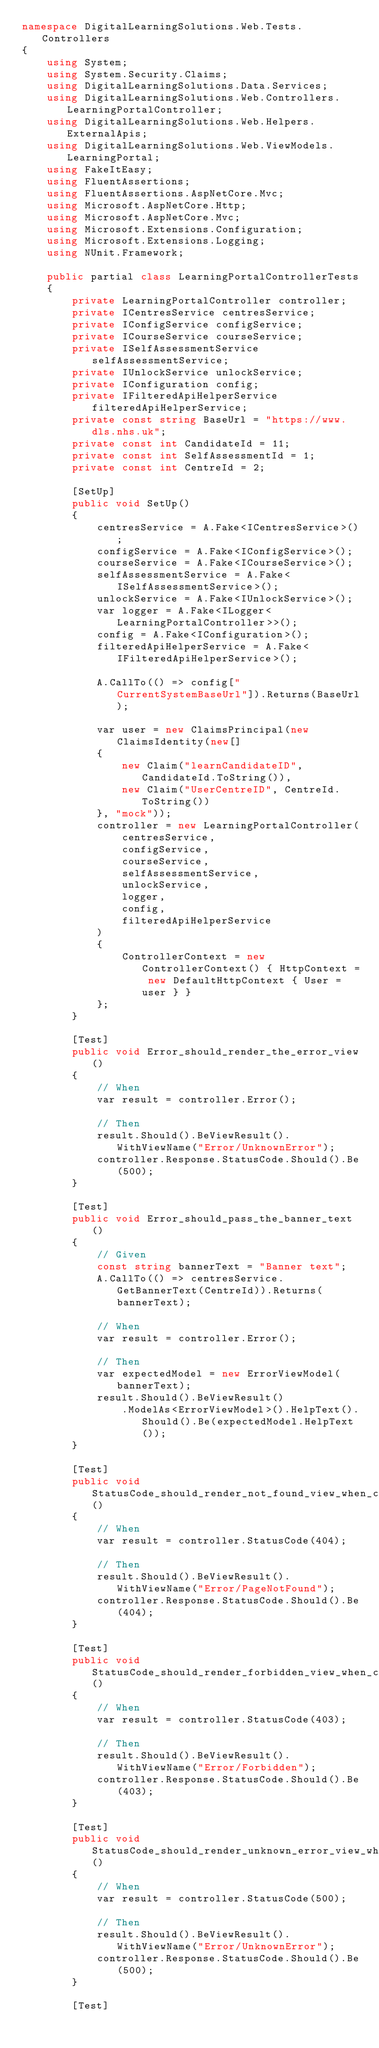Convert code to text. <code><loc_0><loc_0><loc_500><loc_500><_C#_>namespace DigitalLearningSolutions.Web.Tests.Controllers
{
    using System;
    using System.Security.Claims;
    using DigitalLearningSolutions.Data.Services;
    using DigitalLearningSolutions.Web.Controllers.LearningPortalController;
    using DigitalLearningSolutions.Web.Helpers.ExternalApis;
    using DigitalLearningSolutions.Web.ViewModels.LearningPortal;
    using FakeItEasy;
    using FluentAssertions;
    using FluentAssertions.AspNetCore.Mvc;
    using Microsoft.AspNetCore.Http;
    using Microsoft.AspNetCore.Mvc;
    using Microsoft.Extensions.Configuration;
    using Microsoft.Extensions.Logging;
    using NUnit.Framework;

    public partial class LearningPortalControllerTests
    {
        private LearningPortalController controller;
        private ICentresService centresService;
        private IConfigService configService;
        private ICourseService courseService;
        private ISelfAssessmentService selfAssessmentService;
        private IUnlockService unlockService;
        private IConfiguration config;
        private IFilteredApiHelperService filteredApiHelperService;
        private const string BaseUrl = "https://www.dls.nhs.uk";
        private const int CandidateId = 11;
        private const int SelfAssessmentId = 1;
        private const int CentreId = 2;

        [SetUp]
        public void SetUp()
        {
            centresService = A.Fake<ICentresService>();
            configService = A.Fake<IConfigService>();
            courseService = A.Fake<ICourseService>();
            selfAssessmentService = A.Fake<ISelfAssessmentService>();
            unlockService = A.Fake<IUnlockService>();
            var logger = A.Fake<ILogger<LearningPortalController>>();
            config = A.Fake<IConfiguration>();
            filteredApiHelperService = A.Fake<IFilteredApiHelperService>();
            
            A.CallTo(() => config["CurrentSystemBaseUrl"]).Returns(BaseUrl);

            var user = new ClaimsPrincipal(new ClaimsIdentity(new[]
            {
                new Claim("learnCandidateID", CandidateId.ToString()),
                new Claim("UserCentreID", CentreId.ToString())
            }, "mock"));
            controller = new LearningPortalController(
                centresService,
                configService,
                courseService,
                selfAssessmentService,
                unlockService,
                logger,
                config,
                filteredApiHelperService
            )
            {
                ControllerContext = new ControllerContext() { HttpContext = new DefaultHttpContext { User = user } }
            };
        }

        [Test]
        public void Error_should_render_the_error_view()
        {
            // When
            var result = controller.Error();

            // Then
            result.Should().BeViewResult().WithViewName("Error/UnknownError");
            controller.Response.StatusCode.Should().Be(500);
        }

        [Test]
        public void Error_should_pass_the_banner_text()
        {
            // Given
            const string bannerText = "Banner text";
            A.CallTo(() => centresService.GetBannerText(CentreId)).Returns(bannerText);

            // When
            var result = controller.Error();

            // Then
            var expectedModel = new ErrorViewModel(bannerText);
            result.Should().BeViewResult()
                .ModelAs<ErrorViewModel>().HelpText().Should().Be(expectedModel.HelpText());
        }

        [Test]
        public void StatusCode_should_render_not_found_view_when_code_is_404()
        {
            // When
            var result = controller.StatusCode(404);

            // Then
            result.Should().BeViewResult().WithViewName("Error/PageNotFound");
            controller.Response.StatusCode.Should().Be(404);
        }

        [Test]
        public void StatusCode_should_render_forbidden_view_when_code_is_403()
        {
            // When
            var result = controller.StatusCode(403);

            // Then
            result.Should().BeViewResult().WithViewName("Error/Forbidden");
            controller.Response.StatusCode.Should().Be(403);
        }

        [Test]
        public void StatusCode_should_render_unknown_error_view_when_code_is_500()
        {
            // When
            var result = controller.StatusCode(500);

            // Then
            result.Should().BeViewResult().WithViewName("Error/UnknownError");
            controller.Response.StatusCode.Should().Be(500);
        }

        [Test]</code> 